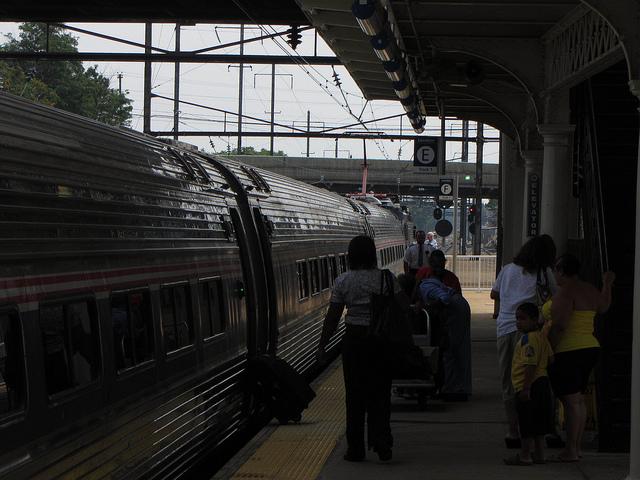What does this train appear to be made of?
Answer briefly. Steel. Are there any animals?
Quick response, please. No. Is the train steam powered?
Write a very short answer. No. Could this be an office building?
Concise answer only. No. 